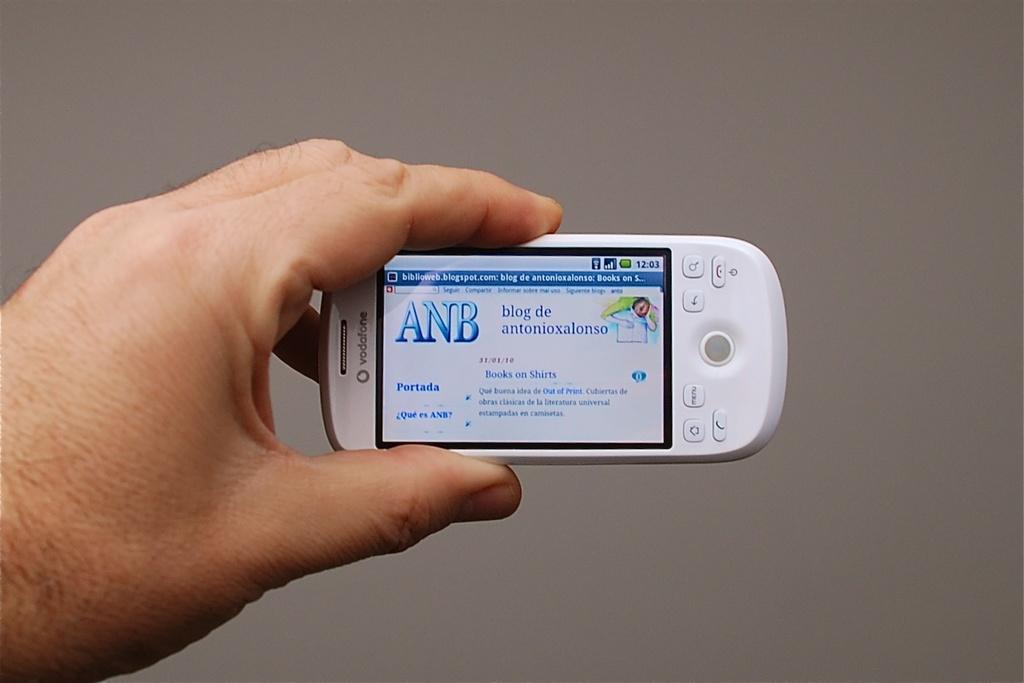What three letters are on this card?
Your answer should be compact. Anb. What does the screen display?
Your answer should be very brief. Anb. 